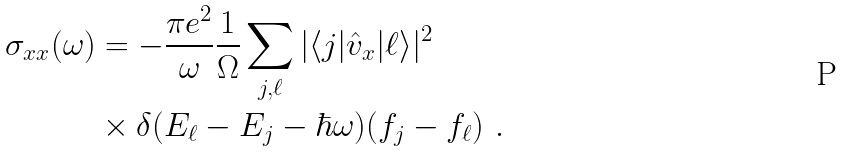<formula> <loc_0><loc_0><loc_500><loc_500>\sigma _ { x x } ( \omega ) & = - \frac { \pi e ^ { 2 } } { \omega } \frac { 1 } { \Omega } \sum _ { j , \ell } | \langle j | \hat { v } _ { x } | \ell \rangle | ^ { 2 } \\ & \times \delta ( E _ { \ell } - E _ { j } - \hbar { \omega } ) ( f _ { j } - f _ { \ell } ) \ .</formula> 